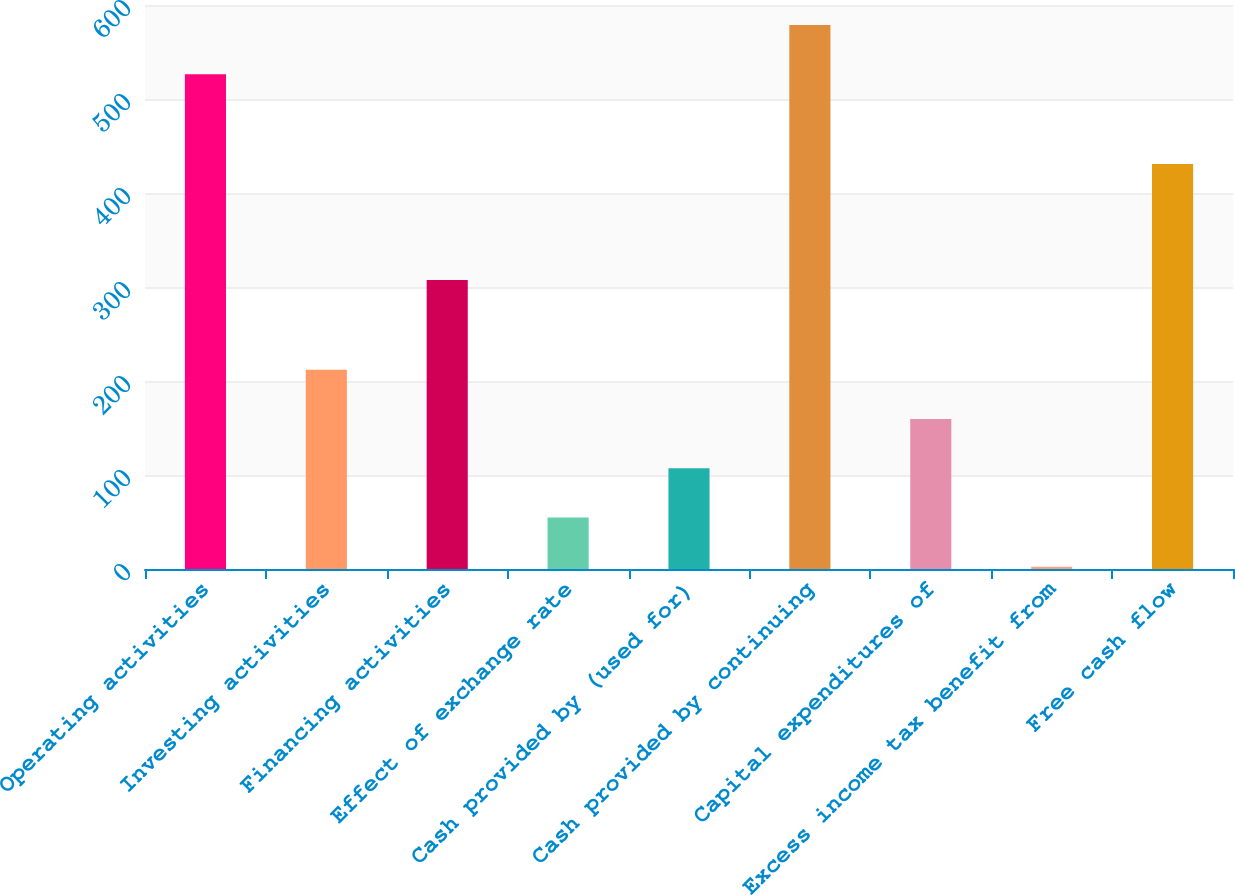Convert chart to OTSL. <chart><loc_0><loc_0><loc_500><loc_500><bar_chart><fcel>Operating activities<fcel>Investing activities<fcel>Financing activities<fcel>Effect of exchange rate<fcel>Cash provided by (used for)<fcel>Cash provided by continuing<fcel>Capital expenditures of<fcel>Excess income tax benefit from<fcel>Free cash flow<nl><fcel>526.4<fcel>212<fcel>307.4<fcel>54.8<fcel>107.2<fcel>578.8<fcel>159.6<fcel>2.4<fcel>430.8<nl></chart> 